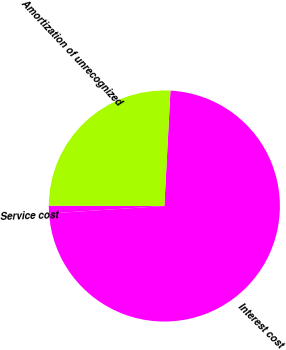Convert chart. <chart><loc_0><loc_0><loc_500><loc_500><pie_chart><fcel>Service cost<fcel>Interest cost<fcel>Amortization of unrecognized<nl><fcel>1.06%<fcel>73.14%<fcel>25.8%<nl></chart> 